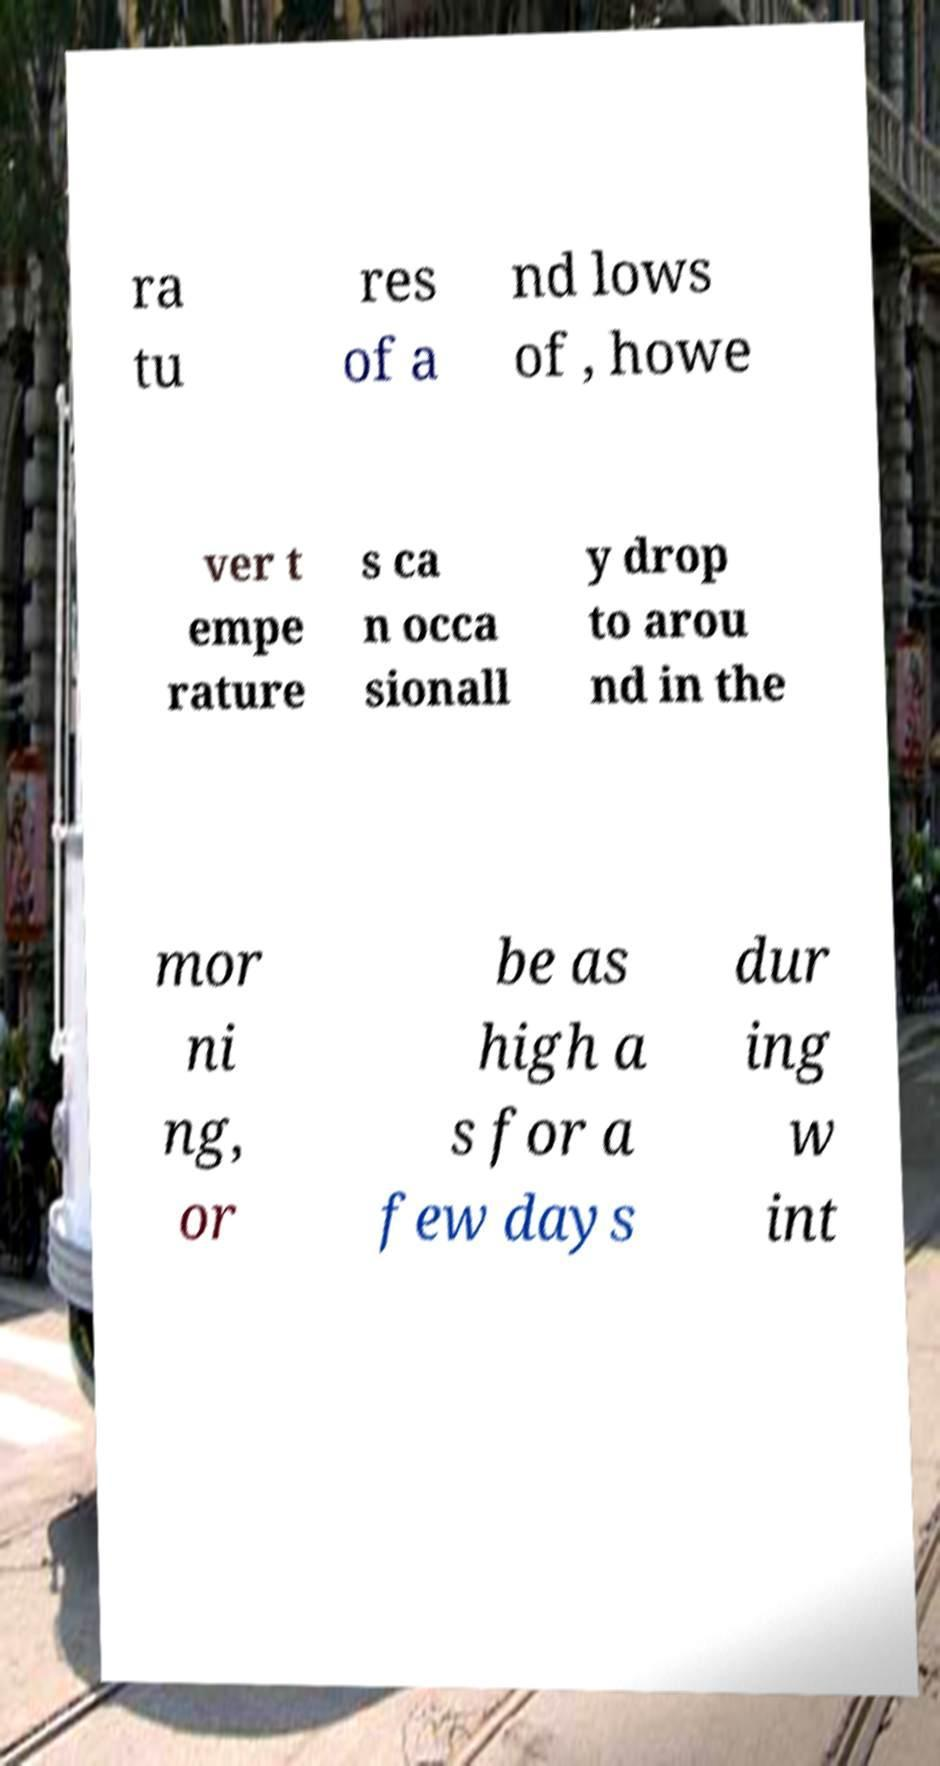Please identify and transcribe the text found in this image. ra tu res of a nd lows of , howe ver t empe rature s ca n occa sionall y drop to arou nd in the mor ni ng, or be as high a s for a few days dur ing w int 